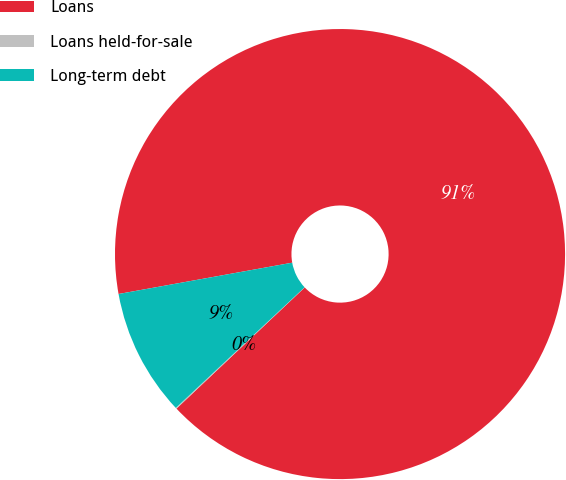<chart> <loc_0><loc_0><loc_500><loc_500><pie_chart><fcel>Loans<fcel>Loans held-for-sale<fcel>Long-term debt<nl><fcel>90.78%<fcel>0.07%<fcel>9.14%<nl></chart> 